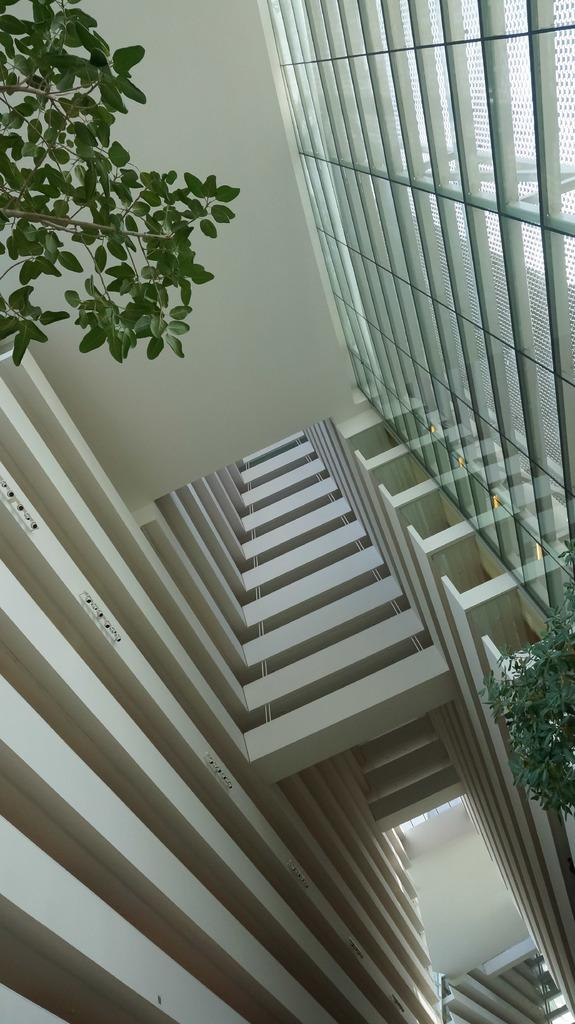What type of view is shown in the image? The image shows an inside view of a building. What can be seen on both sides of the image? There are leaves on both sides of the image. Can you describe a specific architectural feature in the image? There is a glass wall on the right top of the image. What statement does the advertisement in the image make about the product? There is no advertisement present in the image, so it is not possible to answer that question. 